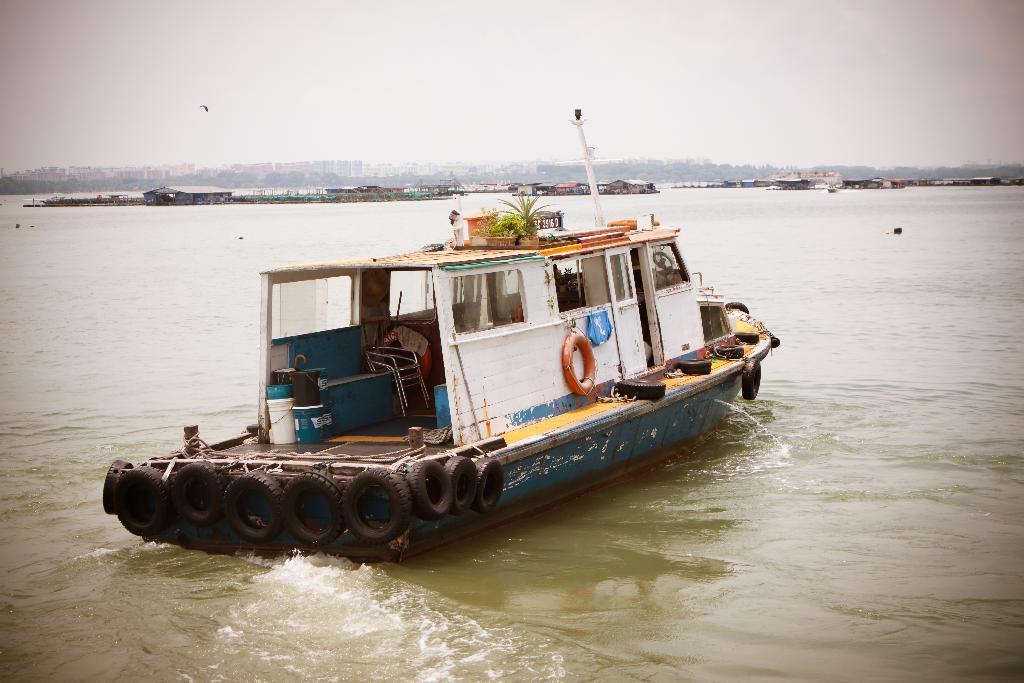Please provide a concise description of this image. In the foreground of this image, there is a boat on the water. In the background, there are few huts, buildings, trees and the sky. 